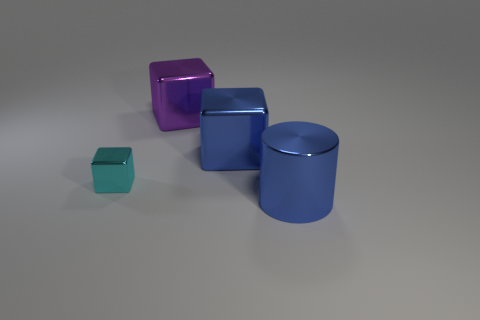Add 1 purple metal cylinders. How many objects exist? 5 Subtract all cylinders. How many objects are left? 3 Subtract all blue metal cylinders. Subtract all big blue things. How many objects are left? 1 Add 2 shiny cylinders. How many shiny cylinders are left? 3 Add 1 large blue metal cylinders. How many large blue metal cylinders exist? 2 Subtract 1 cyan cubes. How many objects are left? 3 